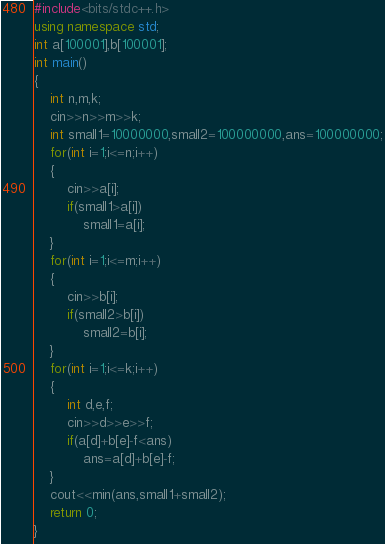Convert code to text. <code><loc_0><loc_0><loc_500><loc_500><_C++_>#include<bits/stdc++.h>
using namespace std;
int a[100001],b[100001];
int main()
{
	int n,m,k;
	cin>>n>>m>>k;
	int small1=10000000,small2=100000000,ans=100000000;
	for(int i=1;i<=n;i++)
	{
		cin>>a[i];
		if(small1>a[i])
			small1=a[i];
	}
	for(int i=1;i<=m;i++)
	{
		cin>>b[i];
		if(small2>b[i])
			small2=b[i];
	}
	for(int i=1;i<=k;i++)
	{
		int d,e,f;
		cin>>d>>e>>f;
		if(a[d]+b[e]-f<ans)
			ans=a[d]+b[e]-f;
	}
	cout<<min(ans,small1+small2);
	return 0;
}</code> 